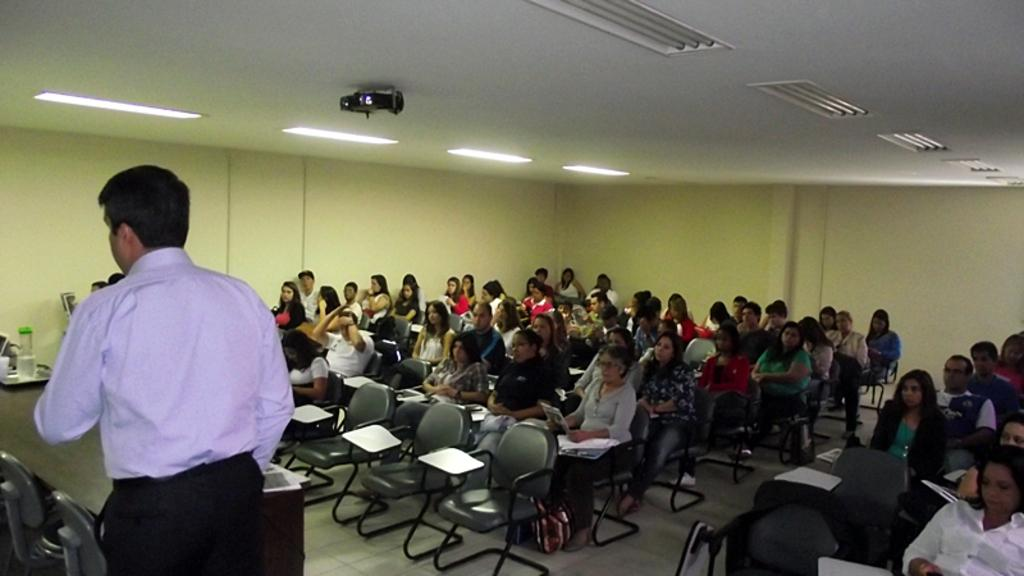What are the people in the image doing? There is a group of people sitting on chairs in the image. Is there anyone standing in the image? Yes, there is a person standing in the image. What can be seen on the table in the image? There are objects on a table in the image. What type of lighting is present in the image? There are lights in the image. What device is used for displaying visuals in the image? There is a projector in the image. How many mittens are visible on the table in the image? There are no mittens present in the image. What type of experience can be observed in the image? The image does not depict a specific experience; it shows a group of people sitting on chairs, a person standing, objects on a table, lights, and a projector. 